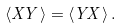Convert formula to latex. <formula><loc_0><loc_0><loc_500><loc_500>\langle X Y \rangle = \langle Y X \rangle \, .</formula> 